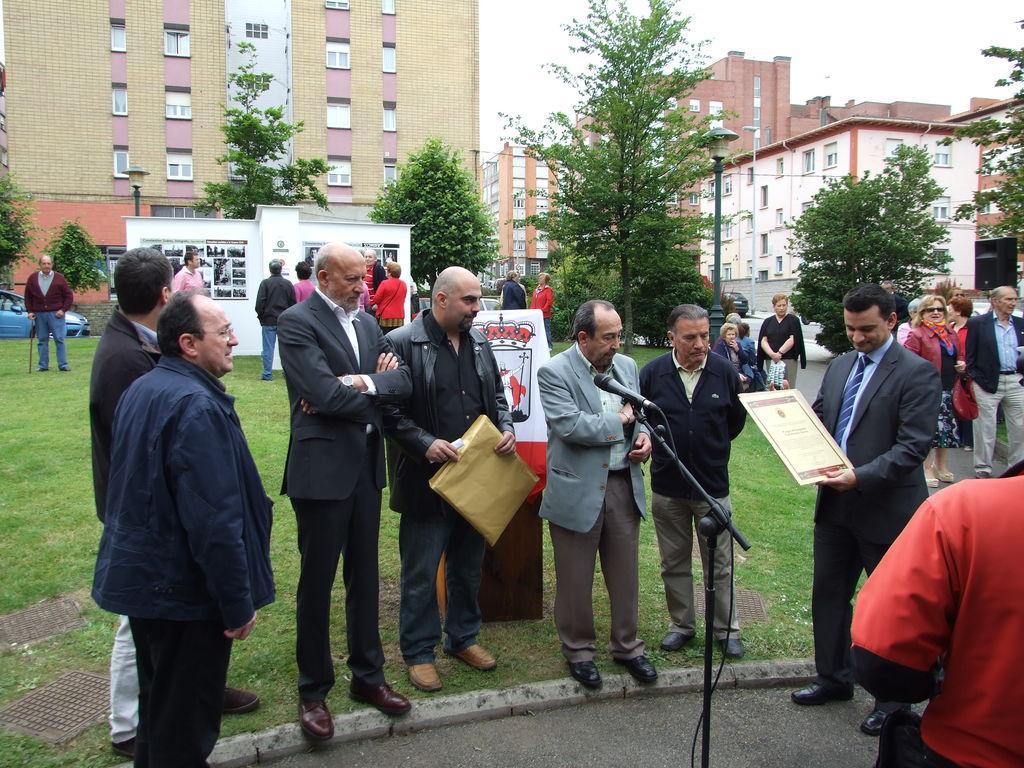Describe this image in one or two sentences. This picture is clicked outside. On the right we can see a person wearing suit, holding an object and standing and we can see a microphone attached to the metal stand and we can see the group of persons standing on the ground and we can see the green grass and some other objects. In the background we can see a vehicle, buildings, trees, lampposts and the sky and some other objects and the group of persons. 